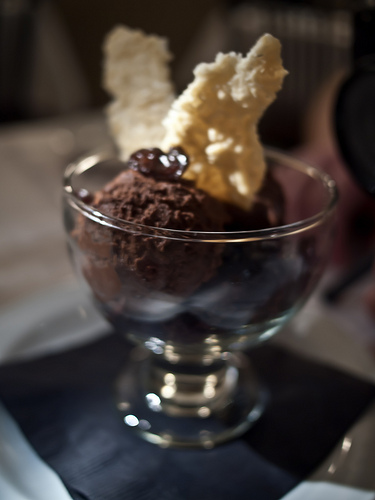<image>
Can you confirm if the ice cream is above the glass? No. The ice cream is not positioned above the glass. The vertical arrangement shows a different relationship. 